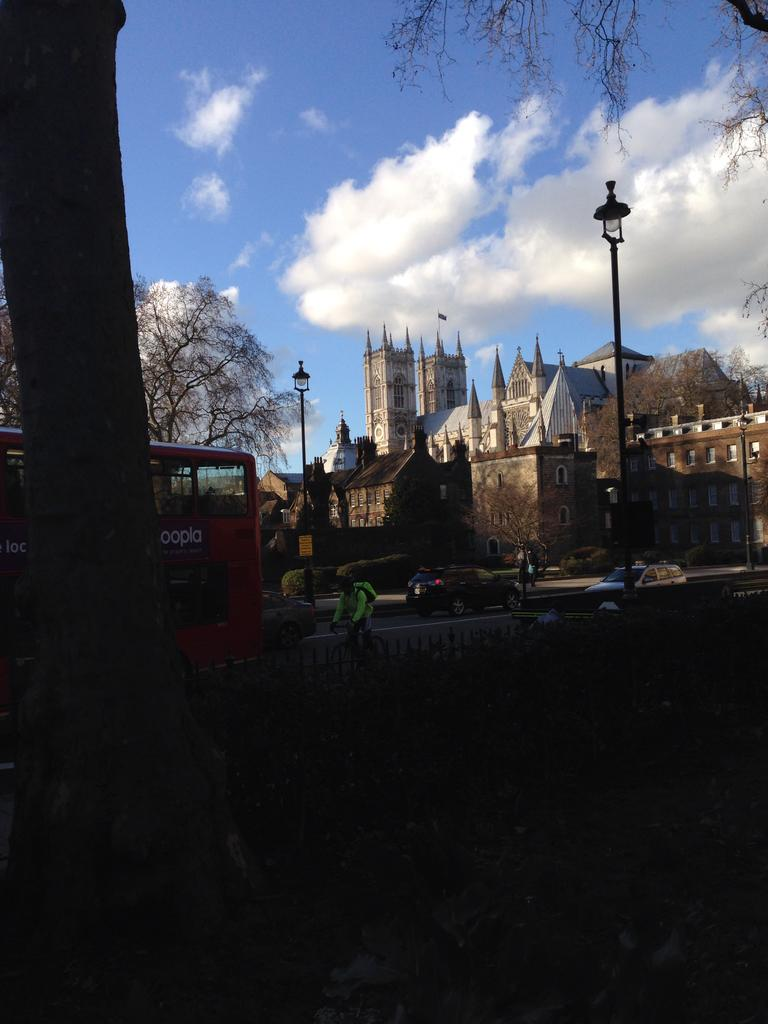What is happening on the road in the image? There are vehicles moving on the road in the image. What structures can be seen in the image? There are buildings in the image. What feature do the buildings have? The buildings have windows. What type of vegetation is present in the image? There are trees in the image. What is the condition of the sky in the image? The sky is clear in the image. What type of test is being conducted on the vehicles in the image? There is no indication of a test being conducted on the vehicles in the image; they are simply moving on the road. Can you see any cast members in the image? There are no cast members present in the image. 